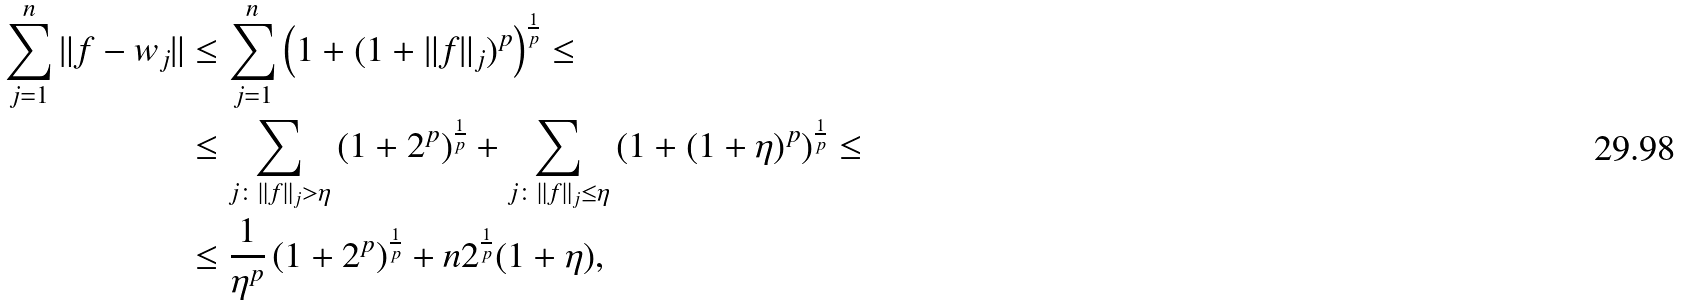<formula> <loc_0><loc_0><loc_500><loc_500>\sum _ { j = 1 } ^ { n } \| f - w _ { j } \| & \leq \sum _ { j = 1 } ^ { n } \left ( 1 + ( 1 + \| f \| _ { j } ) ^ { p } \right ) ^ { \frac { 1 } { p } } \leq \\ & \leq \sum _ { j \colon \| f \| _ { j } > \eta } \left ( 1 + 2 ^ { p } \right ) ^ { \frac { 1 } { p } } + \sum _ { j \colon \| f \| _ { j } \leq \eta } \left ( 1 + ( 1 + \eta ) ^ { p } \right ) ^ { \frac { 1 } { p } } \leq \\ & \leq \frac { 1 } { \eta ^ { p } } \left ( 1 + 2 ^ { p } \right ) ^ { \frac { 1 } { p } } + n 2 ^ { \frac { 1 } { p } } ( 1 + \eta ) ,</formula> 